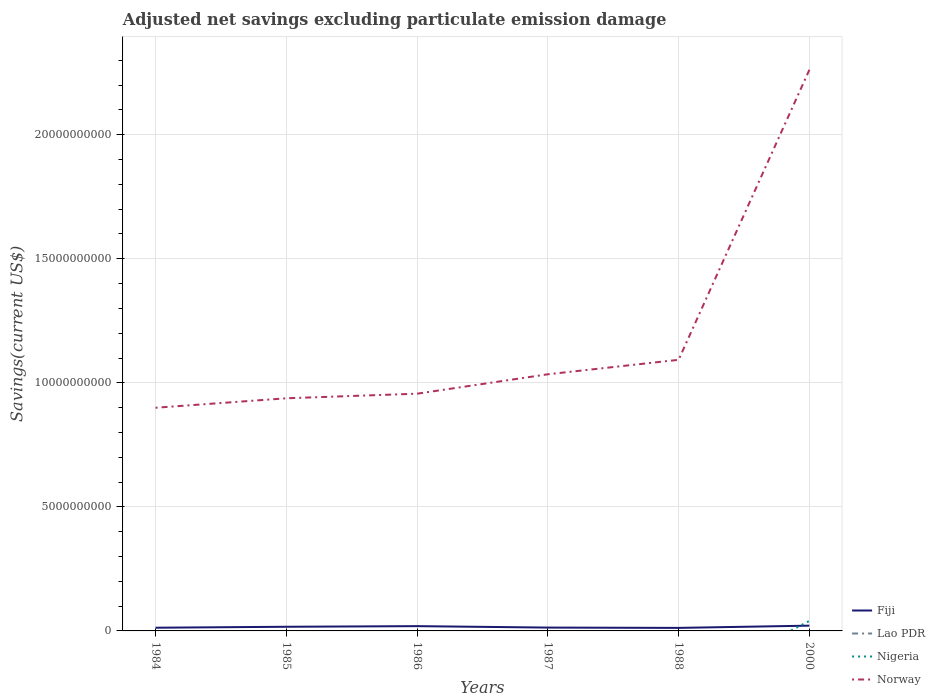Is the number of lines equal to the number of legend labels?
Make the answer very short. No. Across all years, what is the maximum adjusted net savings in Fiji?
Your answer should be compact. 1.22e+08. What is the total adjusted net savings in Fiji in the graph?
Make the answer very short. -4.50e+07. What is the difference between the highest and the second highest adjusted net savings in Nigeria?
Your response must be concise. 4.05e+08. How many lines are there?
Keep it short and to the point. 3. How many years are there in the graph?
Give a very brief answer. 6. What is the difference between two consecutive major ticks on the Y-axis?
Provide a short and direct response. 5.00e+09. What is the title of the graph?
Make the answer very short. Adjusted net savings excluding particulate emission damage. Does "Greenland" appear as one of the legend labels in the graph?
Your answer should be compact. No. What is the label or title of the Y-axis?
Give a very brief answer. Savings(current US$). What is the Savings(current US$) of Fiji in 1984?
Give a very brief answer. 1.29e+08. What is the Savings(current US$) of Lao PDR in 1984?
Give a very brief answer. 0. What is the Savings(current US$) in Norway in 1984?
Offer a very short reply. 9.00e+09. What is the Savings(current US$) in Fiji in 1985?
Offer a terse response. 1.67e+08. What is the Savings(current US$) in Lao PDR in 1985?
Offer a terse response. 0. What is the Savings(current US$) of Nigeria in 1985?
Ensure brevity in your answer.  0. What is the Savings(current US$) of Norway in 1985?
Keep it short and to the point. 9.38e+09. What is the Savings(current US$) in Fiji in 1986?
Your response must be concise. 1.93e+08. What is the Savings(current US$) in Lao PDR in 1986?
Provide a short and direct response. 0. What is the Savings(current US$) of Norway in 1986?
Make the answer very short. 9.56e+09. What is the Savings(current US$) in Fiji in 1987?
Your answer should be very brief. 1.35e+08. What is the Savings(current US$) of Nigeria in 1987?
Offer a terse response. 0. What is the Savings(current US$) in Norway in 1987?
Your response must be concise. 1.03e+1. What is the Savings(current US$) in Fiji in 1988?
Keep it short and to the point. 1.22e+08. What is the Savings(current US$) in Nigeria in 1988?
Ensure brevity in your answer.  0. What is the Savings(current US$) in Norway in 1988?
Your response must be concise. 1.09e+1. What is the Savings(current US$) of Fiji in 2000?
Your response must be concise. 2.12e+08. What is the Savings(current US$) of Nigeria in 2000?
Keep it short and to the point. 4.05e+08. What is the Savings(current US$) of Norway in 2000?
Provide a short and direct response. 2.26e+1. Across all years, what is the maximum Savings(current US$) of Fiji?
Offer a terse response. 2.12e+08. Across all years, what is the maximum Savings(current US$) of Nigeria?
Keep it short and to the point. 4.05e+08. Across all years, what is the maximum Savings(current US$) of Norway?
Provide a short and direct response. 2.26e+1. Across all years, what is the minimum Savings(current US$) in Fiji?
Your response must be concise. 1.22e+08. Across all years, what is the minimum Savings(current US$) in Norway?
Provide a short and direct response. 9.00e+09. What is the total Savings(current US$) in Fiji in the graph?
Ensure brevity in your answer.  9.59e+08. What is the total Savings(current US$) of Nigeria in the graph?
Provide a short and direct response. 4.05e+08. What is the total Savings(current US$) of Norway in the graph?
Offer a terse response. 7.18e+1. What is the difference between the Savings(current US$) of Fiji in 1984 and that in 1985?
Keep it short and to the point. -3.80e+07. What is the difference between the Savings(current US$) in Norway in 1984 and that in 1985?
Ensure brevity in your answer.  -3.82e+08. What is the difference between the Savings(current US$) of Fiji in 1984 and that in 1986?
Give a very brief answer. -6.34e+07. What is the difference between the Savings(current US$) in Norway in 1984 and that in 1986?
Ensure brevity in your answer.  -5.67e+08. What is the difference between the Savings(current US$) in Fiji in 1984 and that in 1987?
Your answer should be very brief. -5.59e+06. What is the difference between the Savings(current US$) in Norway in 1984 and that in 1987?
Offer a terse response. -1.35e+09. What is the difference between the Savings(current US$) in Fiji in 1984 and that in 1988?
Keep it short and to the point. 7.43e+06. What is the difference between the Savings(current US$) in Norway in 1984 and that in 1988?
Ensure brevity in your answer.  -1.93e+09. What is the difference between the Savings(current US$) of Fiji in 1984 and that in 2000?
Provide a succinct answer. -8.30e+07. What is the difference between the Savings(current US$) of Norway in 1984 and that in 2000?
Give a very brief answer. -1.36e+1. What is the difference between the Savings(current US$) in Fiji in 1985 and that in 1986?
Your response must be concise. -2.54e+07. What is the difference between the Savings(current US$) of Norway in 1985 and that in 1986?
Offer a terse response. -1.86e+08. What is the difference between the Savings(current US$) in Fiji in 1985 and that in 1987?
Make the answer very short. 3.24e+07. What is the difference between the Savings(current US$) of Norway in 1985 and that in 1987?
Provide a short and direct response. -9.67e+08. What is the difference between the Savings(current US$) in Fiji in 1985 and that in 1988?
Make the answer very short. 4.54e+07. What is the difference between the Savings(current US$) of Norway in 1985 and that in 1988?
Give a very brief answer. -1.55e+09. What is the difference between the Savings(current US$) in Fiji in 1985 and that in 2000?
Ensure brevity in your answer.  -4.50e+07. What is the difference between the Savings(current US$) in Norway in 1985 and that in 2000?
Ensure brevity in your answer.  -1.32e+1. What is the difference between the Savings(current US$) of Fiji in 1986 and that in 1987?
Ensure brevity in your answer.  5.78e+07. What is the difference between the Savings(current US$) of Norway in 1986 and that in 1987?
Provide a short and direct response. -7.82e+08. What is the difference between the Savings(current US$) in Fiji in 1986 and that in 1988?
Your answer should be compact. 7.08e+07. What is the difference between the Savings(current US$) of Norway in 1986 and that in 1988?
Your answer should be compact. -1.37e+09. What is the difference between the Savings(current US$) of Fiji in 1986 and that in 2000?
Provide a succinct answer. -1.96e+07. What is the difference between the Savings(current US$) of Norway in 1986 and that in 2000?
Give a very brief answer. -1.31e+1. What is the difference between the Savings(current US$) of Fiji in 1987 and that in 1988?
Offer a terse response. 1.30e+07. What is the difference between the Savings(current US$) in Norway in 1987 and that in 1988?
Your response must be concise. -5.83e+08. What is the difference between the Savings(current US$) of Fiji in 1987 and that in 2000?
Offer a terse response. -7.74e+07. What is the difference between the Savings(current US$) of Norway in 1987 and that in 2000?
Keep it short and to the point. -1.23e+1. What is the difference between the Savings(current US$) of Fiji in 1988 and that in 2000?
Make the answer very short. -9.04e+07. What is the difference between the Savings(current US$) of Norway in 1988 and that in 2000?
Offer a terse response. -1.17e+1. What is the difference between the Savings(current US$) in Fiji in 1984 and the Savings(current US$) in Norway in 1985?
Provide a short and direct response. -9.25e+09. What is the difference between the Savings(current US$) of Fiji in 1984 and the Savings(current US$) of Norway in 1986?
Provide a short and direct response. -9.43e+09. What is the difference between the Savings(current US$) of Fiji in 1984 and the Savings(current US$) of Norway in 1987?
Provide a short and direct response. -1.02e+1. What is the difference between the Savings(current US$) in Fiji in 1984 and the Savings(current US$) in Norway in 1988?
Your answer should be compact. -1.08e+1. What is the difference between the Savings(current US$) in Fiji in 1984 and the Savings(current US$) in Nigeria in 2000?
Your response must be concise. -2.76e+08. What is the difference between the Savings(current US$) of Fiji in 1984 and the Savings(current US$) of Norway in 2000?
Provide a short and direct response. -2.25e+1. What is the difference between the Savings(current US$) of Fiji in 1985 and the Savings(current US$) of Norway in 1986?
Keep it short and to the point. -9.39e+09. What is the difference between the Savings(current US$) of Fiji in 1985 and the Savings(current US$) of Norway in 1987?
Your response must be concise. -1.02e+1. What is the difference between the Savings(current US$) of Fiji in 1985 and the Savings(current US$) of Norway in 1988?
Ensure brevity in your answer.  -1.08e+1. What is the difference between the Savings(current US$) in Fiji in 1985 and the Savings(current US$) in Nigeria in 2000?
Your answer should be very brief. -2.38e+08. What is the difference between the Savings(current US$) of Fiji in 1985 and the Savings(current US$) of Norway in 2000?
Keep it short and to the point. -2.24e+1. What is the difference between the Savings(current US$) in Fiji in 1986 and the Savings(current US$) in Norway in 1987?
Make the answer very short. -1.02e+1. What is the difference between the Savings(current US$) of Fiji in 1986 and the Savings(current US$) of Norway in 1988?
Your response must be concise. -1.07e+1. What is the difference between the Savings(current US$) of Fiji in 1986 and the Savings(current US$) of Nigeria in 2000?
Your answer should be compact. -2.12e+08. What is the difference between the Savings(current US$) of Fiji in 1986 and the Savings(current US$) of Norway in 2000?
Ensure brevity in your answer.  -2.24e+1. What is the difference between the Savings(current US$) of Fiji in 1987 and the Savings(current US$) of Norway in 1988?
Offer a very short reply. -1.08e+1. What is the difference between the Savings(current US$) of Fiji in 1987 and the Savings(current US$) of Nigeria in 2000?
Your answer should be very brief. -2.70e+08. What is the difference between the Savings(current US$) in Fiji in 1987 and the Savings(current US$) in Norway in 2000?
Make the answer very short. -2.25e+1. What is the difference between the Savings(current US$) of Fiji in 1988 and the Savings(current US$) of Nigeria in 2000?
Provide a short and direct response. -2.83e+08. What is the difference between the Savings(current US$) in Fiji in 1988 and the Savings(current US$) in Norway in 2000?
Give a very brief answer. -2.25e+1. What is the average Savings(current US$) in Fiji per year?
Offer a very short reply. 1.60e+08. What is the average Savings(current US$) in Nigeria per year?
Make the answer very short. 6.75e+07. What is the average Savings(current US$) of Norway per year?
Ensure brevity in your answer.  1.20e+1. In the year 1984, what is the difference between the Savings(current US$) of Fiji and Savings(current US$) of Norway?
Make the answer very short. -8.87e+09. In the year 1985, what is the difference between the Savings(current US$) in Fiji and Savings(current US$) in Norway?
Ensure brevity in your answer.  -9.21e+09. In the year 1986, what is the difference between the Savings(current US$) of Fiji and Savings(current US$) of Norway?
Your response must be concise. -9.37e+09. In the year 1987, what is the difference between the Savings(current US$) in Fiji and Savings(current US$) in Norway?
Offer a very short reply. -1.02e+1. In the year 1988, what is the difference between the Savings(current US$) of Fiji and Savings(current US$) of Norway?
Provide a succinct answer. -1.08e+1. In the year 2000, what is the difference between the Savings(current US$) in Fiji and Savings(current US$) in Nigeria?
Keep it short and to the point. -1.93e+08. In the year 2000, what is the difference between the Savings(current US$) in Fiji and Savings(current US$) in Norway?
Offer a very short reply. -2.24e+1. In the year 2000, what is the difference between the Savings(current US$) of Nigeria and Savings(current US$) of Norway?
Provide a succinct answer. -2.22e+1. What is the ratio of the Savings(current US$) in Fiji in 1984 to that in 1985?
Keep it short and to the point. 0.77. What is the ratio of the Savings(current US$) in Norway in 1984 to that in 1985?
Give a very brief answer. 0.96. What is the ratio of the Savings(current US$) in Fiji in 1984 to that in 1986?
Give a very brief answer. 0.67. What is the ratio of the Savings(current US$) in Norway in 1984 to that in 1986?
Offer a very short reply. 0.94. What is the ratio of the Savings(current US$) in Fiji in 1984 to that in 1987?
Provide a succinct answer. 0.96. What is the ratio of the Savings(current US$) in Norway in 1984 to that in 1987?
Offer a terse response. 0.87. What is the ratio of the Savings(current US$) in Fiji in 1984 to that in 1988?
Give a very brief answer. 1.06. What is the ratio of the Savings(current US$) of Norway in 1984 to that in 1988?
Provide a succinct answer. 0.82. What is the ratio of the Savings(current US$) in Fiji in 1984 to that in 2000?
Your answer should be compact. 0.61. What is the ratio of the Savings(current US$) in Norway in 1984 to that in 2000?
Give a very brief answer. 0.4. What is the ratio of the Savings(current US$) of Fiji in 1985 to that in 1986?
Your answer should be compact. 0.87. What is the ratio of the Savings(current US$) in Norway in 1985 to that in 1986?
Your response must be concise. 0.98. What is the ratio of the Savings(current US$) of Fiji in 1985 to that in 1987?
Make the answer very short. 1.24. What is the ratio of the Savings(current US$) in Norway in 1985 to that in 1987?
Your answer should be compact. 0.91. What is the ratio of the Savings(current US$) in Fiji in 1985 to that in 1988?
Your answer should be compact. 1.37. What is the ratio of the Savings(current US$) of Norway in 1985 to that in 1988?
Your response must be concise. 0.86. What is the ratio of the Savings(current US$) in Fiji in 1985 to that in 2000?
Make the answer very short. 0.79. What is the ratio of the Savings(current US$) of Norway in 1985 to that in 2000?
Offer a terse response. 0.41. What is the ratio of the Savings(current US$) in Fiji in 1986 to that in 1987?
Give a very brief answer. 1.43. What is the ratio of the Savings(current US$) of Norway in 1986 to that in 1987?
Your response must be concise. 0.92. What is the ratio of the Savings(current US$) of Fiji in 1986 to that in 1988?
Offer a very short reply. 1.58. What is the ratio of the Savings(current US$) of Norway in 1986 to that in 1988?
Give a very brief answer. 0.88. What is the ratio of the Savings(current US$) in Fiji in 1986 to that in 2000?
Your answer should be very brief. 0.91. What is the ratio of the Savings(current US$) of Norway in 1986 to that in 2000?
Give a very brief answer. 0.42. What is the ratio of the Savings(current US$) in Fiji in 1987 to that in 1988?
Offer a terse response. 1.11. What is the ratio of the Savings(current US$) in Norway in 1987 to that in 1988?
Your answer should be very brief. 0.95. What is the ratio of the Savings(current US$) of Fiji in 1987 to that in 2000?
Offer a terse response. 0.64. What is the ratio of the Savings(current US$) in Norway in 1987 to that in 2000?
Provide a succinct answer. 0.46. What is the ratio of the Savings(current US$) in Fiji in 1988 to that in 2000?
Provide a succinct answer. 0.57. What is the ratio of the Savings(current US$) in Norway in 1988 to that in 2000?
Your response must be concise. 0.48. What is the difference between the highest and the second highest Savings(current US$) in Fiji?
Offer a very short reply. 1.96e+07. What is the difference between the highest and the second highest Savings(current US$) in Norway?
Your answer should be very brief. 1.17e+1. What is the difference between the highest and the lowest Savings(current US$) of Fiji?
Ensure brevity in your answer.  9.04e+07. What is the difference between the highest and the lowest Savings(current US$) of Nigeria?
Make the answer very short. 4.05e+08. What is the difference between the highest and the lowest Savings(current US$) of Norway?
Your response must be concise. 1.36e+1. 